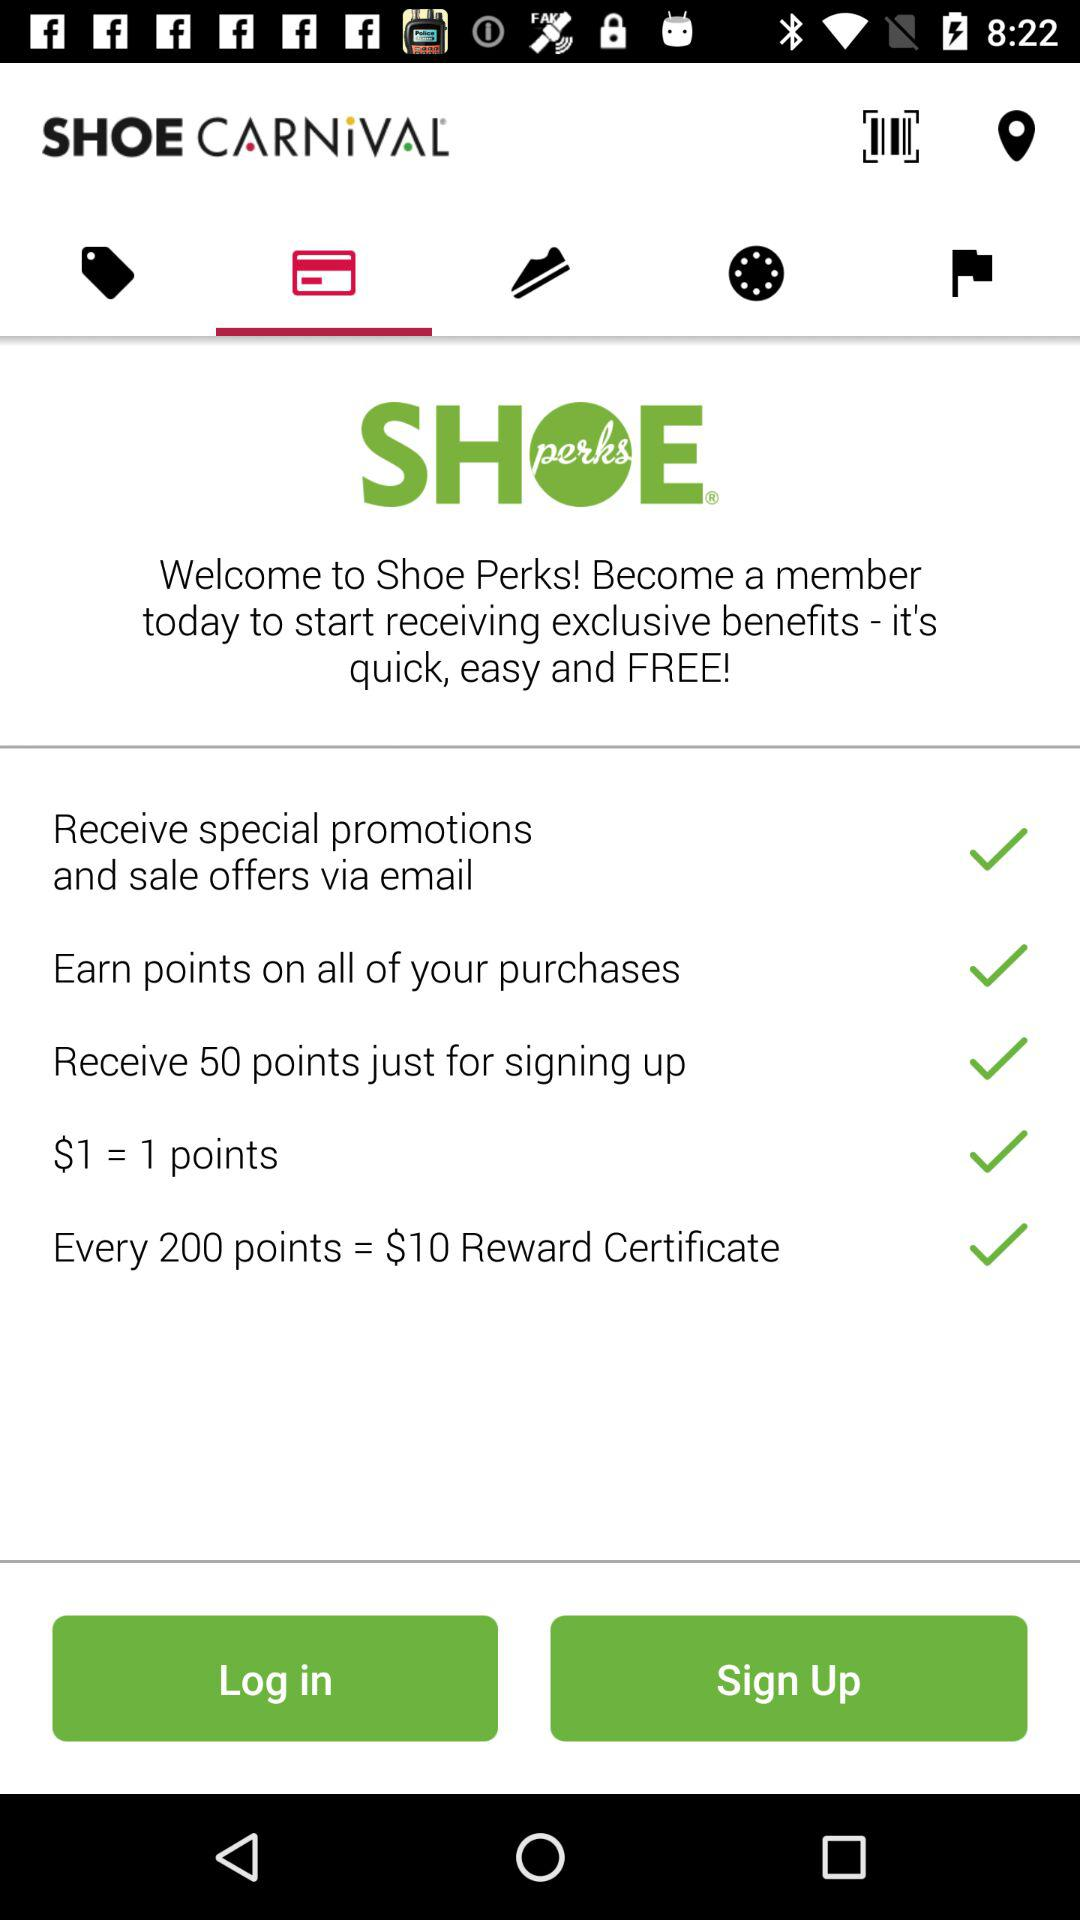How many points is $1 worth? One dollar equals one point. 